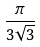<formula> <loc_0><loc_0><loc_500><loc_500>\frac { \pi } { 3 \sqrt { 3 } }</formula> 